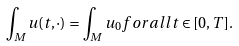Convert formula to latex. <formula><loc_0><loc_0><loc_500><loc_500>\int _ { M } u ( t , \cdot ) = \int _ { M } u _ { 0 } f o r a l l t \in [ 0 , T ] .</formula> 